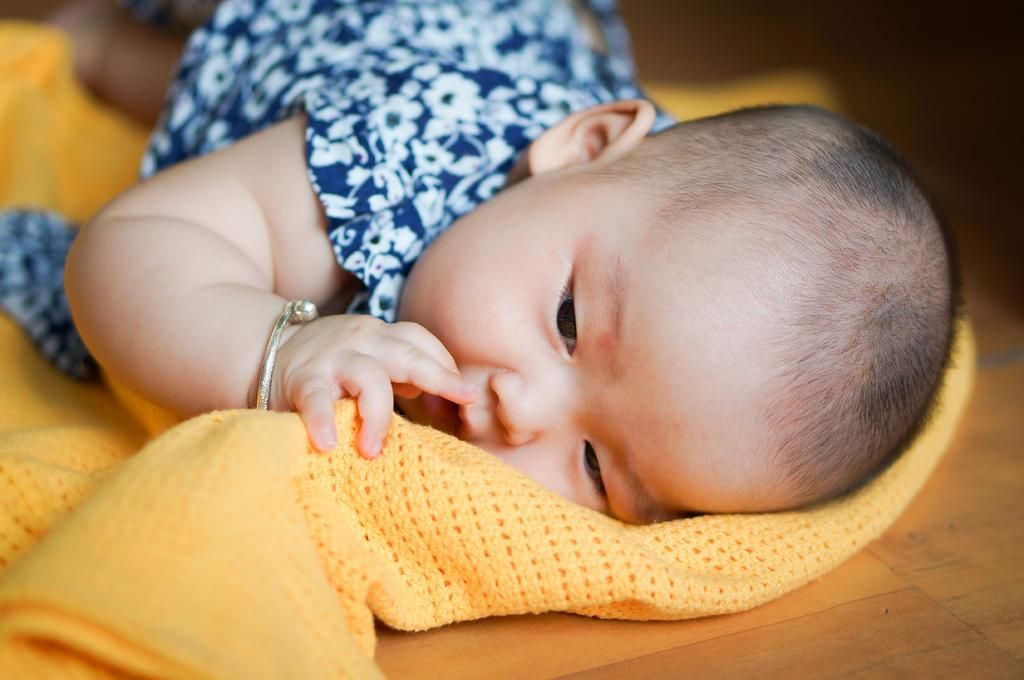What is the main subject of the image? There is a baby in the image. What is the baby wearing? The baby is wearing a bangle. What is the baby lying on? The baby is lying on a cloth. What is the cloth placed on? The cloth is on another surface. What type of straw is the baby using to play a game in the image? There is no straw or game present in the image; it only features a baby lying on a cloth. 